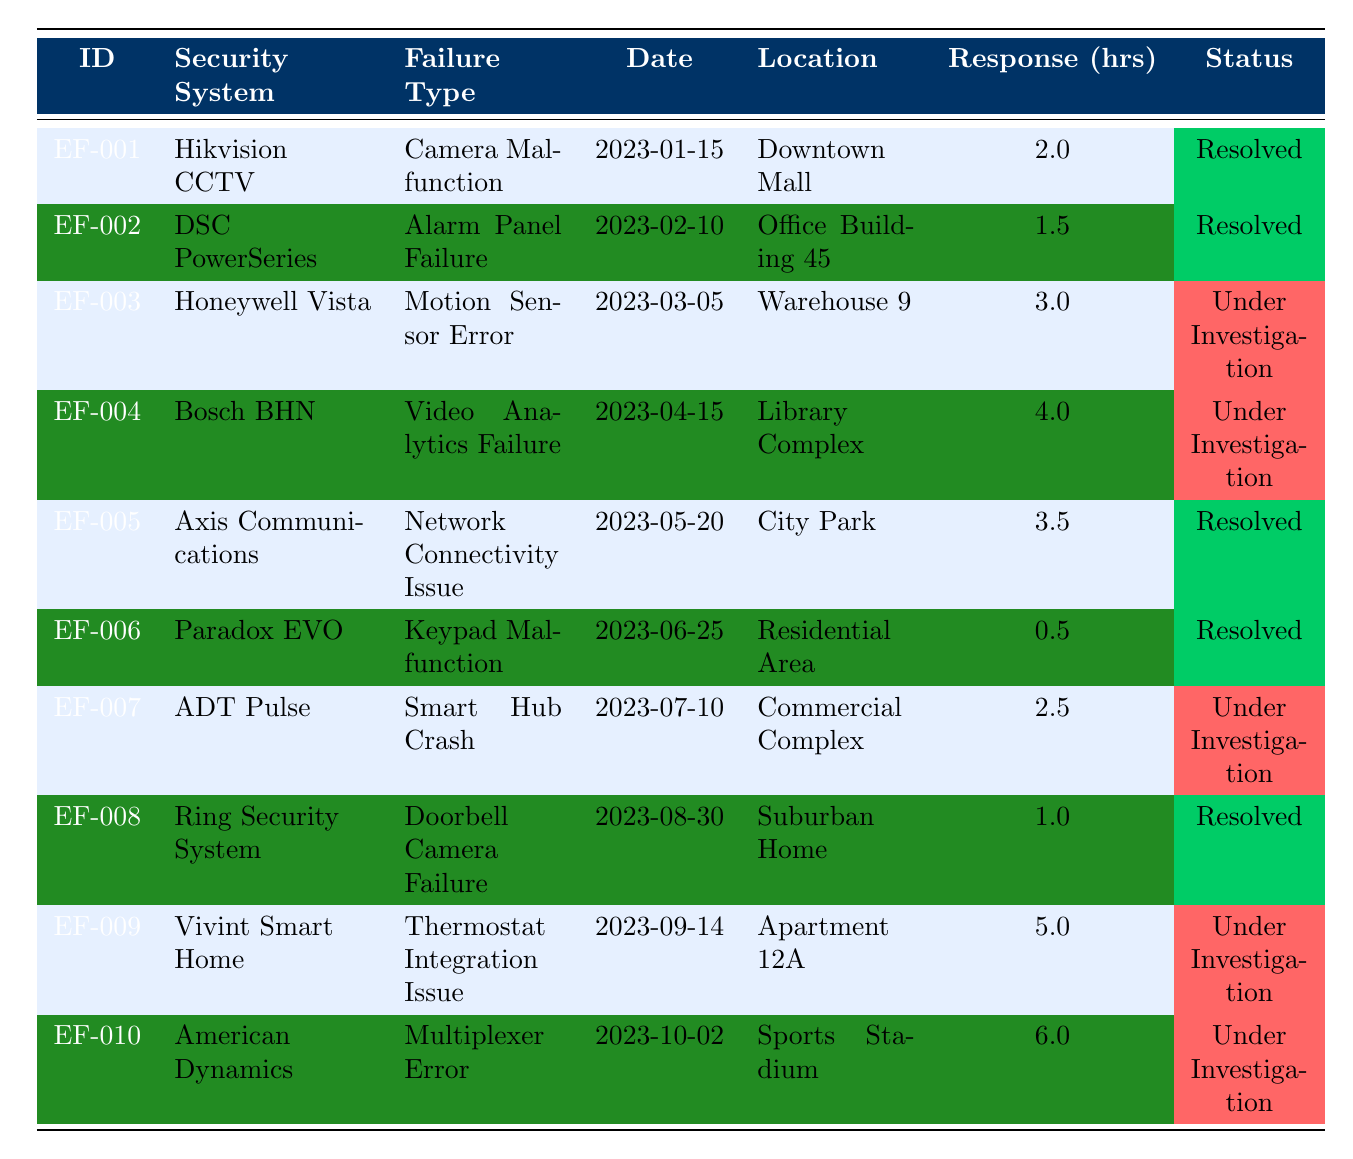What is the incident ID for the Camera Malfunction? To find the incident ID, I look for the row where the failure type is "Camera Malfunction." It is listed in the first row as EF-001.
Answer: EF-001 How many incidents were reported in total? By counting the rows in the table, I find there are 10 incidents listed.
Answer: 10 Which security system had the longest response time? To determine the longest response time, I compare the values under the "Response (hrs)" column. The maximum value is 6.0 hours for the American Dynamics system.
Answer: American Dynamics How many incidents are still under investigation? I check the "Status" column and count the rows marked as "Under Investigation." There are 4 such incidents: EF-003, EF-004, EF-007, and EF-009.
Answer: 4 What is the average response time for all resolved incidents? I sum the response times for resolved incidents (2.0 + 1.5 + 3.5 + 0.5 + 1.0 = 8.5 hours) and divide by the number of resolved incidents (5). The average is 8.5/5 = 1.7 hours.
Answer: 1.7 Is there an incident related to a video analytics failure? I search the "Failure Type" column for "Video Analytics Failure," which I find listed under incident EF-004.
Answer: Yes Which incident reported on 2023-06-25 had a response time under 1 hour? I check the table for the date 2023-06-25 and see that the incident related to Paradox EVO had a response time of 0.5 hours, which is under 1 hour.
Answer: No incident met that criterion What was the average response time for security systems that had resolution set? I sum the response times for resolved incidents (2.0 + 1.5 + 3.5 + 0.5 + 1.0 = 8.5 hours) and divide by the number of resolved incidents (5) to get an average of 1.7 hours.
Answer: 1.7 Which location reported the incident with the longest response time? I find the response time of 6.0 hours listed under the American Dynamics incident, located at the Sports Stadium, which is the longest.
Answer: Sports Stadium Are there any incidents that reported issues after May 1, 2023? I examine the dates reported and find that incidents EF-007, EF-008, EF-009, and EF-010 all occurred after May 1, 2023.
Answer: Yes 